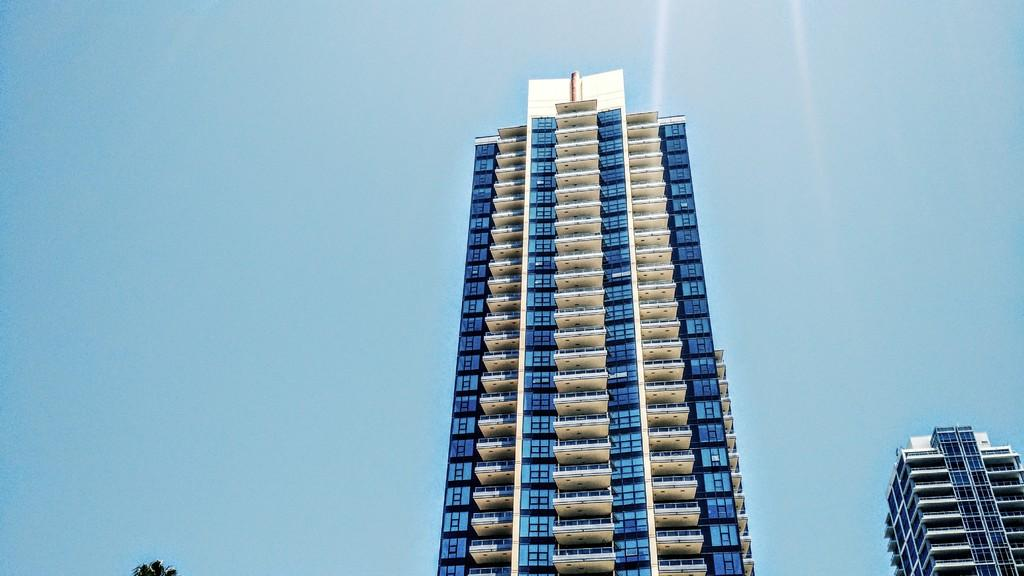What type of structures can be seen in the image? There are buildings in the image. What feature can be found on the buildings? There is a glass window in the image. What is the condition of the sky in the image? The sky is clear in the image. Can you hear the buildings laughing in the image? Buildings do not have the ability to laugh, so there is no laughter heard in the image. What type of crate is visible in the image? There is no crate present in the image. 